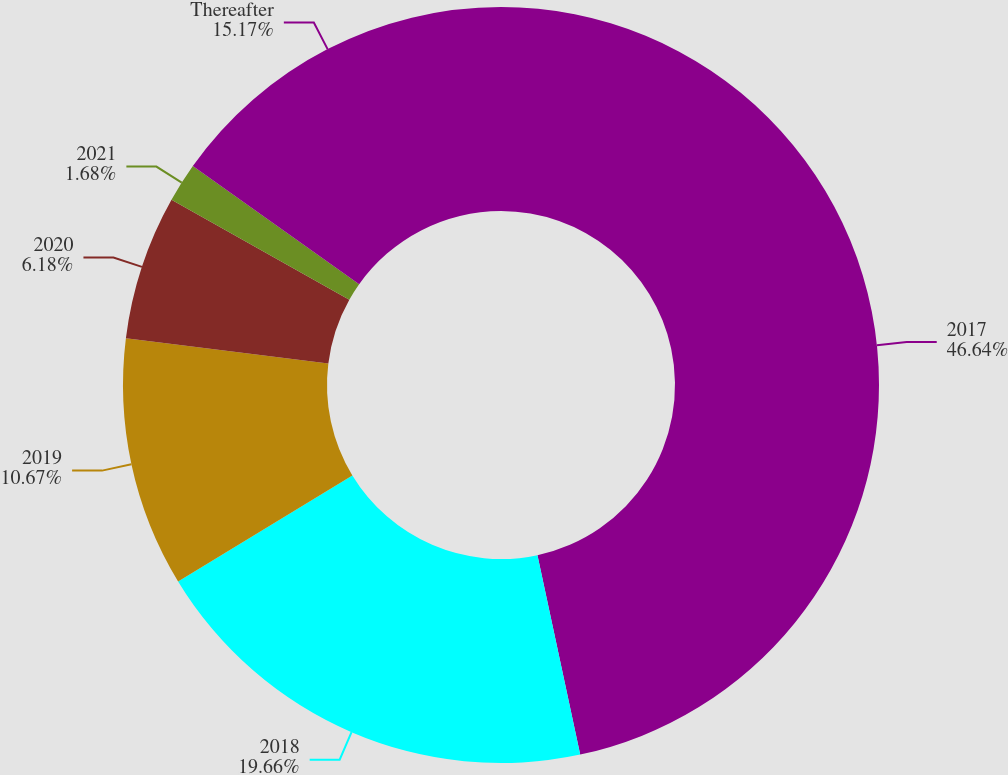Convert chart to OTSL. <chart><loc_0><loc_0><loc_500><loc_500><pie_chart><fcel>2017<fcel>2018<fcel>2019<fcel>2020<fcel>2021<fcel>Thereafter<nl><fcel>46.64%<fcel>19.66%<fcel>10.67%<fcel>6.18%<fcel>1.68%<fcel>15.17%<nl></chart> 